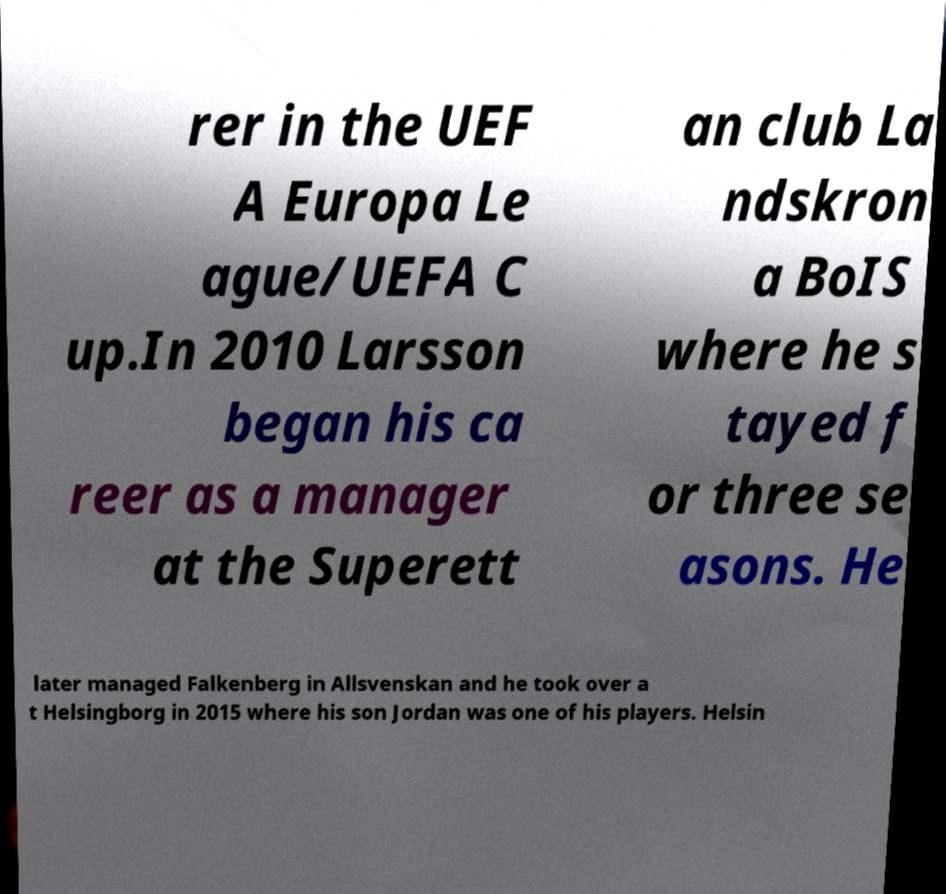Could you extract and type out the text from this image? rer in the UEF A Europa Le ague/UEFA C up.In 2010 Larsson began his ca reer as a manager at the Superett an club La ndskron a BoIS where he s tayed f or three se asons. He later managed Falkenberg in Allsvenskan and he took over a t Helsingborg in 2015 where his son Jordan was one of his players. Helsin 